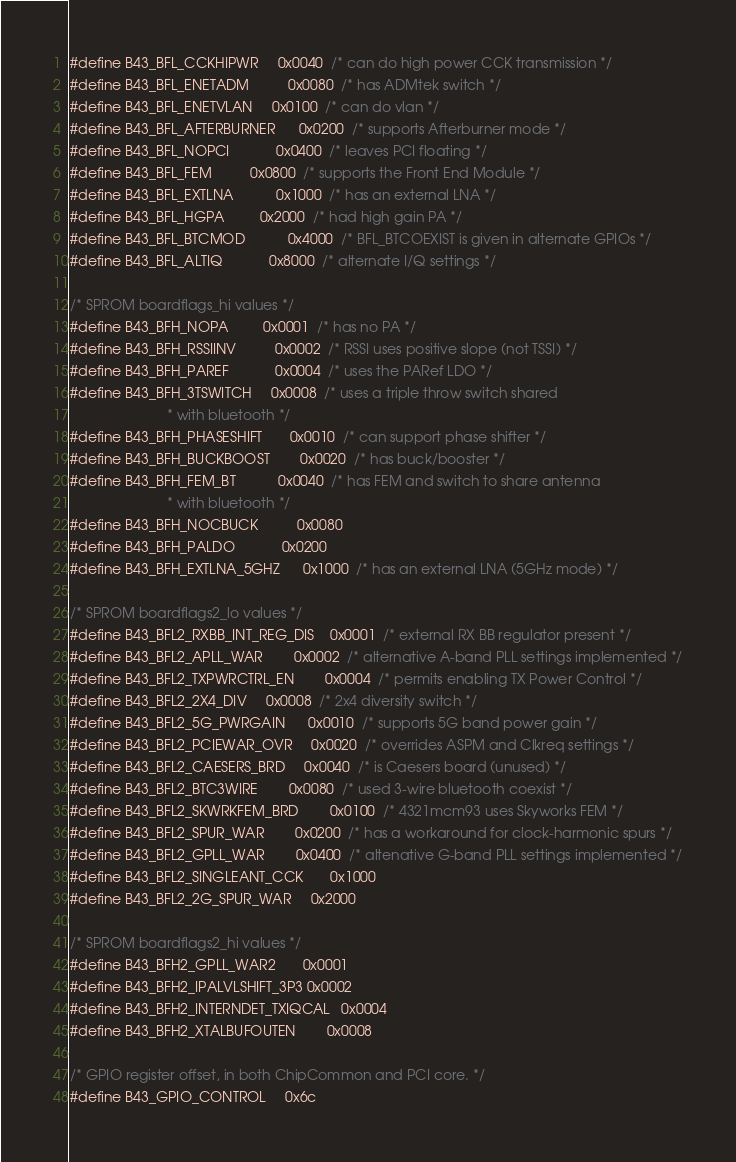Convert code to text. <code><loc_0><loc_0><loc_500><loc_500><_C_>#define B43_BFL_CCKHIPWR		0x0040	/* can do high power CCK transmission */
#define B43_BFL_ENETADM			0x0080	/* has ADMtek switch */
#define B43_BFL_ENETVLAN		0x0100	/* can do vlan */
#define B43_BFL_AFTERBURNER		0x0200	/* supports Afterburner mode */
#define B43_BFL_NOPCI			0x0400	/* leaves PCI floating */
#define B43_BFL_FEM			0x0800	/* supports the Front End Module */
#define B43_BFL_EXTLNA			0x1000	/* has an external LNA */
#define B43_BFL_HGPA			0x2000	/* had high gain PA */
#define B43_BFL_BTCMOD			0x4000	/* BFL_BTCOEXIST is given in alternate GPIOs */
#define B43_BFL_ALTIQ			0x8000	/* alternate I/Q settings */

/* SPROM boardflags_hi values */
#define B43_BFH_NOPA			0x0001	/* has no PA */
#define B43_BFH_RSSIINV			0x0002	/* RSSI uses positive slope (not TSSI) */
#define B43_BFH_PAREF			0x0004	/* uses the PARef LDO */
#define B43_BFH_3TSWITCH		0x0008	/* uses a triple throw switch shared
						 * with bluetooth */
#define B43_BFH_PHASESHIFT		0x0010	/* can support phase shifter */
#define B43_BFH_BUCKBOOST		0x0020	/* has buck/booster */
#define B43_BFH_FEM_BT			0x0040	/* has FEM and switch to share antenna
						 * with bluetooth */
#define B43_BFH_NOCBUCK			0x0080
#define B43_BFH_PALDO			0x0200
#define B43_BFH_EXTLNA_5GHZ		0x1000	/* has an external LNA (5GHz mode) */

/* SPROM boardflags2_lo values */
#define B43_BFL2_RXBB_INT_REG_DIS	0x0001	/* external RX BB regulator present */
#define B43_BFL2_APLL_WAR		0x0002	/* alternative A-band PLL settings implemented */
#define B43_BFL2_TXPWRCTRL_EN 		0x0004	/* permits enabling TX Power Control */
#define B43_BFL2_2X4_DIV		0x0008	/* 2x4 diversity switch */
#define B43_BFL2_5G_PWRGAIN		0x0010	/* supports 5G band power gain */
#define B43_BFL2_PCIEWAR_OVR		0x0020	/* overrides ASPM and Clkreq settings */
#define B43_BFL2_CAESERS_BRD		0x0040	/* is Caesers board (unused) */
#define B43_BFL2_BTC3WIRE		0x0080	/* used 3-wire bluetooth coexist */
#define B43_BFL2_SKWRKFEM_BRD		0x0100	/* 4321mcm93 uses Skyworks FEM */
#define B43_BFL2_SPUR_WAR		0x0200	/* has a workaround for clock-harmonic spurs */
#define B43_BFL2_GPLL_WAR		0x0400	/* altenative G-band PLL settings implemented */
#define B43_BFL2_SINGLEANT_CCK		0x1000
#define B43_BFL2_2G_SPUR_WAR		0x2000

/* SPROM boardflags2_hi values */
#define B43_BFH2_GPLL_WAR2		0x0001
#define B43_BFH2_IPALVLSHIFT_3P3	0x0002
#define B43_BFH2_INTERNDET_TXIQCAL	0x0004
#define B43_BFH2_XTALBUFOUTEN		0x0008

/* GPIO register offset, in both ChipCommon and PCI core. */
#define B43_GPIO_CONTROL		0x6c
</code> 